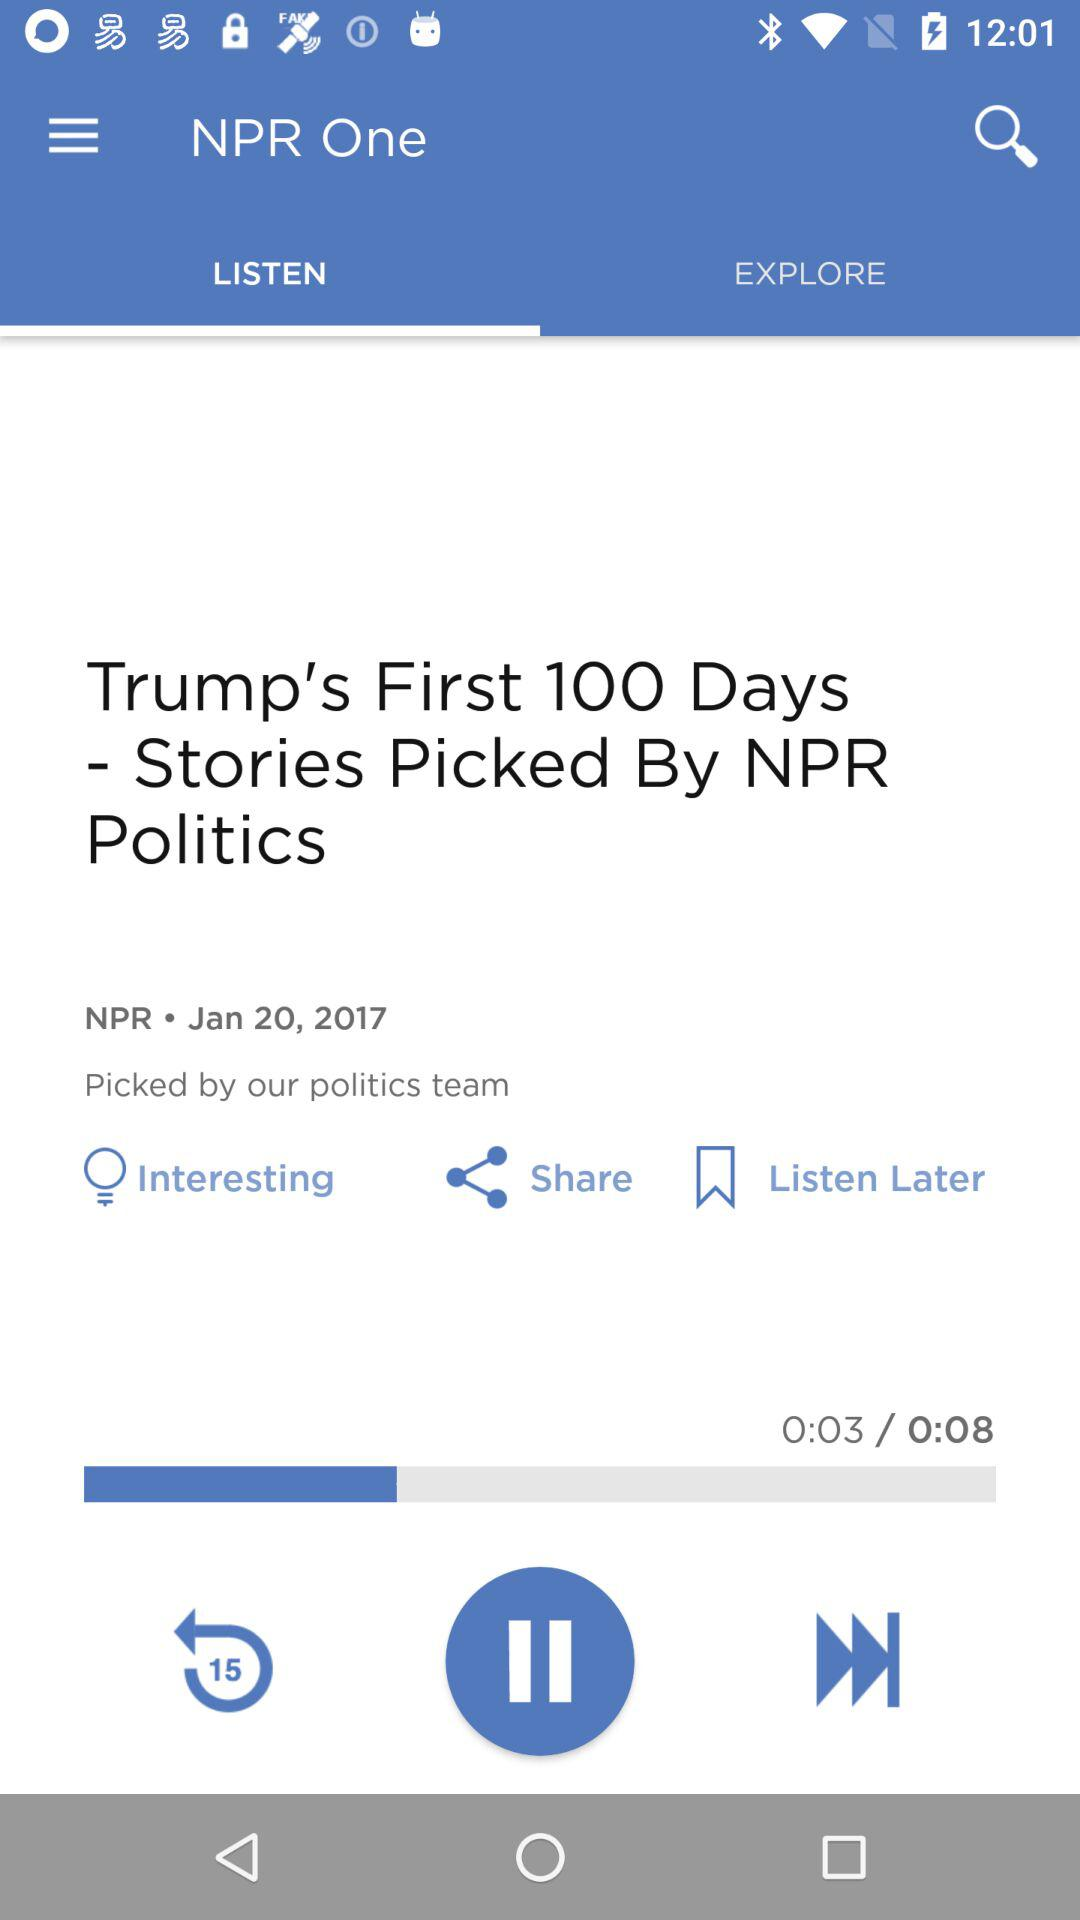What duration am I at? You are at 0:03 duration. 